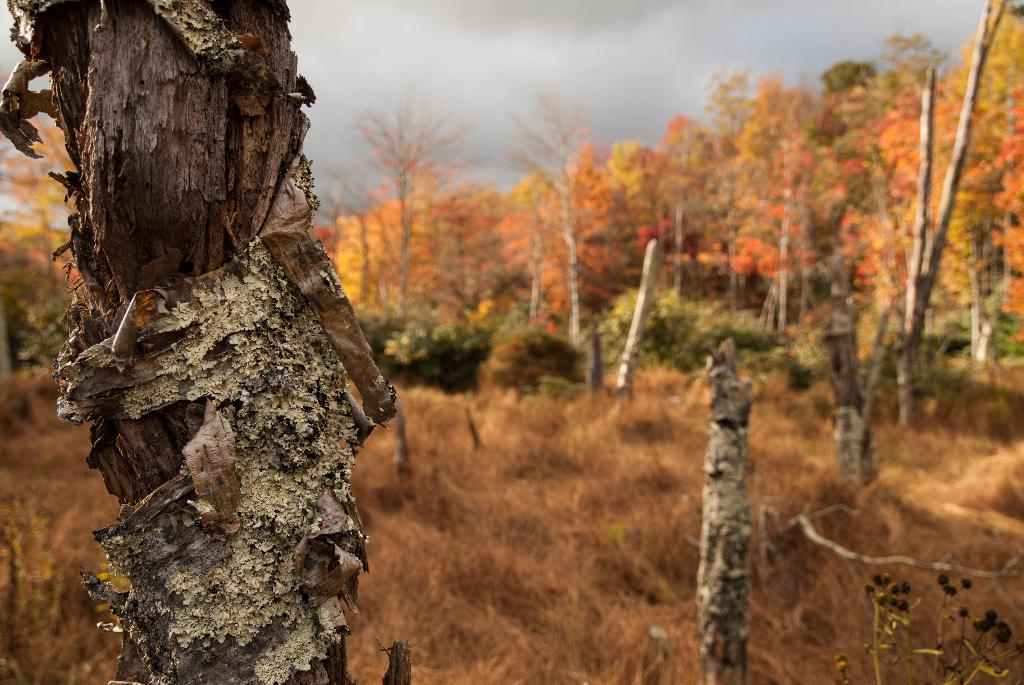What is the main object in the foreground of the image? There is a tree branch in the foreground of the image. What type of vegetation is present in the image? There are dried grass plants in the image. What can be seen in the background of the image? Trees and the sky are visible in the background of the image. What is the condition of the sky in the image? Clouds are present in the sky. What type of wire is being used to hold the tree branch in the image? There is no wire present in the image; the tree branch is resting on the ground or other objects. Can you see a toad hopping on the dried grass plants in the image? There is no toad visible in the image; only the tree branch, dried grass plants, trees, and sky are present. 